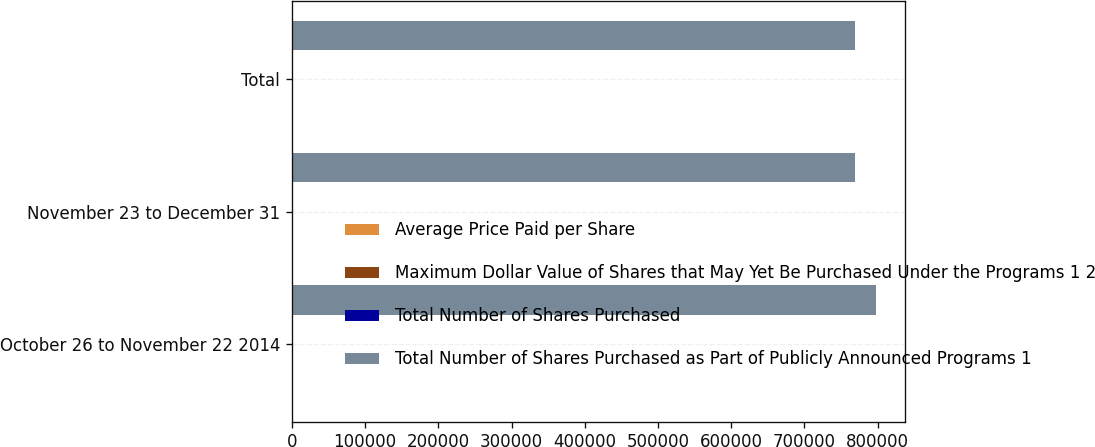<chart> <loc_0><loc_0><loc_500><loc_500><stacked_bar_chart><ecel><fcel>October 26 to November 22 2014<fcel>November 23 to December 31<fcel>Total<nl><fcel>Average Price Paid per Share<fcel>405<fcel>263<fcel>668<nl><fcel>Maximum Dollar Value of Shares that May Yet Be Purchased Under the Programs 1 2<fcel>112.33<fcel>115.51<fcel>113.58<nl><fcel>Total Number of Shares Purchased<fcel>405<fcel>250<fcel>655<nl><fcel>Total Number of Shares Purchased as Part of Publicly Announced Programs 1<fcel>797661<fcel>768758<fcel>768758<nl></chart> 